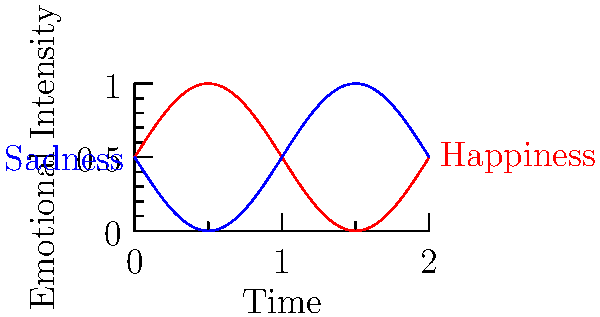In the color-coded line graph depicting a protagonist's emotional journey, what narrative technique is being illustrated by the alternating peaks and valleys of the red and blue lines? To answer this question, let's analyze the graph step-by-step:

1. The graph shows two lines: a red line and a blue line.
2. The red line is labeled "Happiness" and the blue line is labeled "Sadness."
3. Both lines follow a sinusoidal pattern, alternating between peaks and valleys.
4. The red line's peaks correspond to the blue line's valleys, and vice versa.
5. This alternating pattern suggests that the protagonist's emotions are fluctuating between happiness and sadness over time.
6. In storytelling, this technique of presenting contrasting emotional states in a cyclical manner is known as "emotional contrast" or "emotional oscillation."
7. This narrative technique is often used to create depth in character development and to maintain reader engagement by presenting a dynamic emotional journey.
8. The use of contrasting emotions helps to highlight the intensity of each emotional state and creates a sense of emotional growth or change in the character.

Given these observations, the narrative technique being illustrated is emotional contrast or oscillation, which is a key element in creating a compelling character arc and maintaining narrative tension.
Answer: Emotional contrast/oscillation 